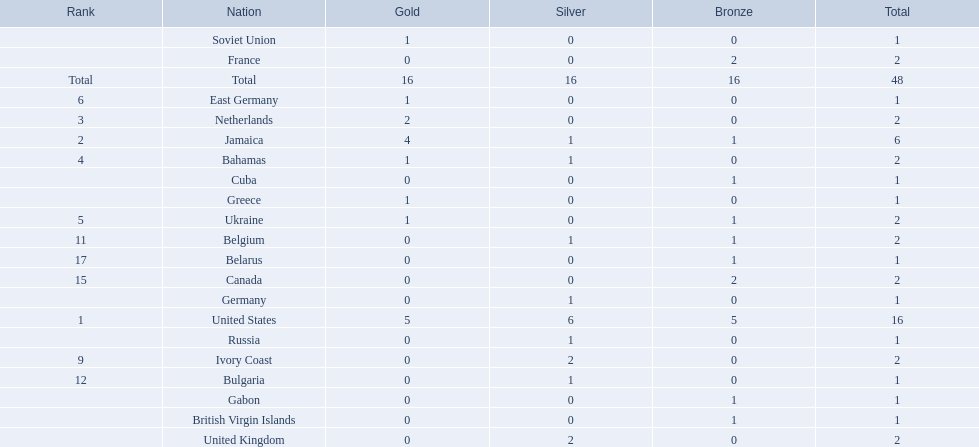What countries competed? United States, Jamaica, Netherlands, Bahamas, Ukraine, East Germany, Greece, Soviet Union, Ivory Coast, United Kingdom, Belgium, Bulgaria, Russia, Germany, Canada, France, Belarus, Cuba, Gabon, British Virgin Islands. Which countries won gold medals? United States, Jamaica, Netherlands, Bahamas, Ukraine, East Germany, Greece, Soviet Union. Which country had the second most medals? Jamaica. 